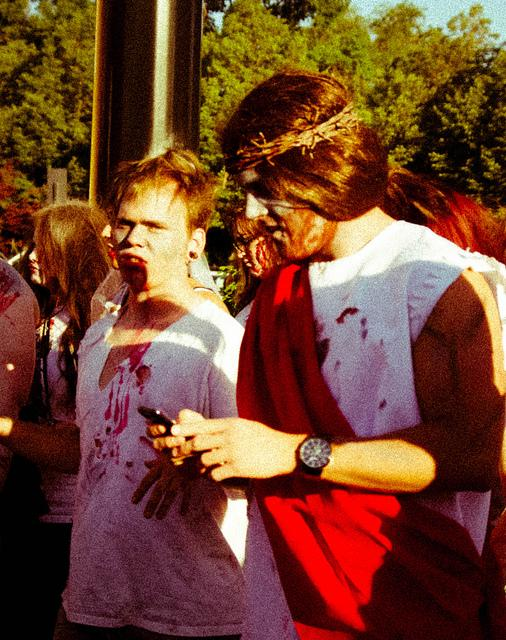What character does the man looking at his cell phone play? Please explain your reasoning. jesus. The clothing indicate that he's role-playing a from christian stories. 